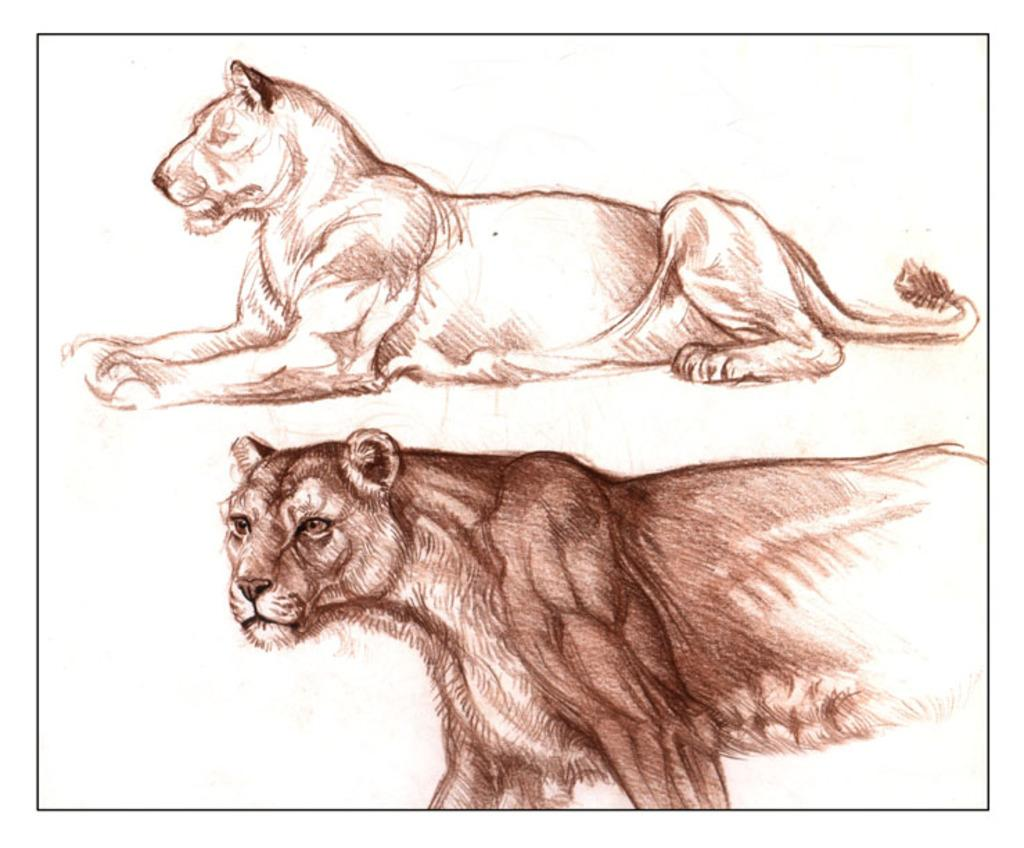What subjects are depicted in the foreground of the image? There is a painting of a lion and a painting of a lioness in the foreground of the image. What color is the background of the image? The background of the image is white in color. What arithmetic problem is being solved by the lion in the image? There is no arithmetic problem being solved by the lion in the image, as it is a painting of a lion and not an actual lion solving a problem. 